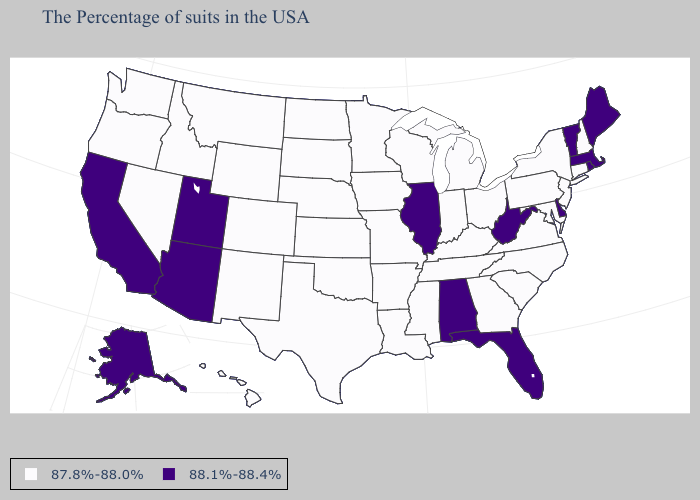Does Florida have the highest value in the USA?
Be succinct. Yes. Name the states that have a value in the range 88.1%-88.4%?
Be succinct. Maine, Massachusetts, Rhode Island, Vermont, Delaware, West Virginia, Florida, Alabama, Illinois, Utah, Arizona, California, Alaska. Among the states that border New York , does Massachusetts have the highest value?
Give a very brief answer. Yes. What is the lowest value in states that border Wyoming?
Be succinct. 87.8%-88.0%. What is the value of Maine?
Be succinct. 88.1%-88.4%. Name the states that have a value in the range 88.1%-88.4%?
Give a very brief answer. Maine, Massachusetts, Rhode Island, Vermont, Delaware, West Virginia, Florida, Alabama, Illinois, Utah, Arizona, California, Alaska. Which states have the highest value in the USA?
Concise answer only. Maine, Massachusetts, Rhode Island, Vermont, Delaware, West Virginia, Florida, Alabama, Illinois, Utah, Arizona, California, Alaska. What is the highest value in the South ?
Answer briefly. 88.1%-88.4%. What is the value of Delaware?
Concise answer only. 88.1%-88.4%. What is the value of Texas?
Quick response, please. 87.8%-88.0%. Does Indiana have the highest value in the MidWest?
Be succinct. No. What is the highest value in the USA?
Concise answer only. 88.1%-88.4%. What is the highest value in the USA?
Short answer required. 88.1%-88.4%. 